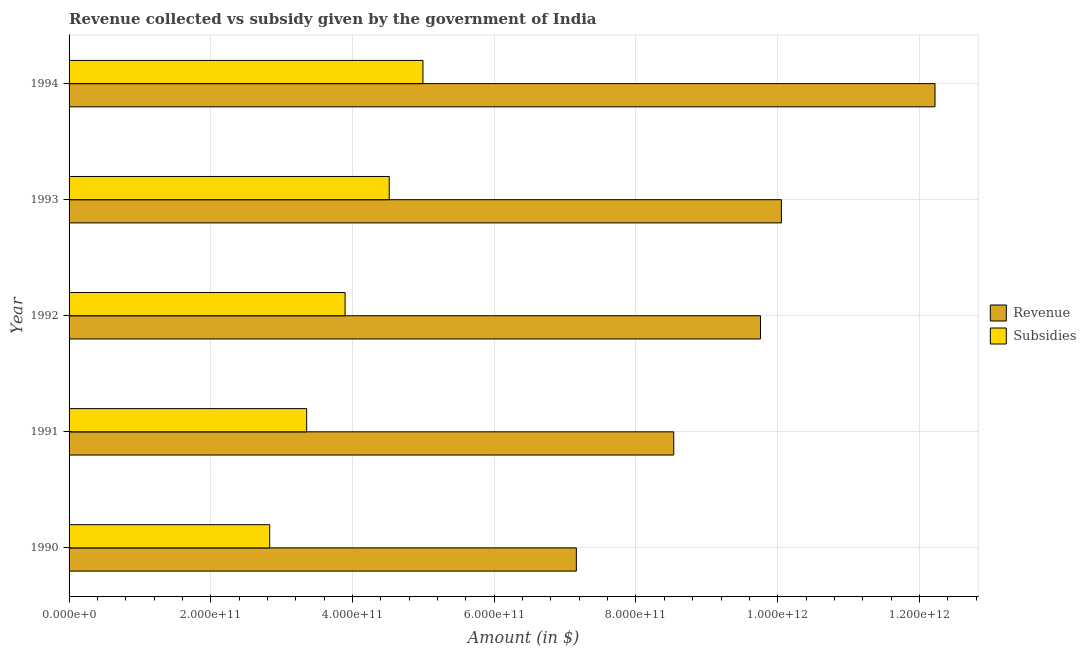Are the number of bars per tick equal to the number of legend labels?
Your response must be concise. Yes. How many bars are there on the 4th tick from the top?
Offer a very short reply. 2. How many bars are there on the 5th tick from the bottom?
Offer a terse response. 2. What is the amount of revenue collected in 1991?
Give a very brief answer. 8.53e+11. Across all years, what is the maximum amount of revenue collected?
Give a very brief answer. 1.22e+12. Across all years, what is the minimum amount of subsidies given?
Offer a terse response. 2.83e+11. What is the total amount of subsidies given in the graph?
Provide a succinct answer. 1.96e+12. What is the difference between the amount of revenue collected in 1990 and that in 1993?
Your answer should be very brief. -2.89e+11. What is the difference between the amount of subsidies given in 1993 and the amount of revenue collected in 1992?
Your answer should be compact. -5.24e+11. What is the average amount of revenue collected per year?
Your answer should be compact. 9.54e+11. In the year 1994, what is the difference between the amount of revenue collected and amount of subsidies given?
Keep it short and to the point. 7.23e+11. What is the ratio of the amount of revenue collected in 1993 to that in 1994?
Your answer should be very brief. 0.82. Is the amount of revenue collected in 1990 less than that in 1994?
Provide a short and direct response. Yes. What is the difference between the highest and the second highest amount of subsidies given?
Keep it short and to the point. 4.76e+1. What is the difference between the highest and the lowest amount of revenue collected?
Provide a short and direct response. 5.06e+11. In how many years, is the amount of subsidies given greater than the average amount of subsidies given taken over all years?
Provide a succinct answer. 2. Is the sum of the amount of revenue collected in 1990 and 1991 greater than the maximum amount of subsidies given across all years?
Give a very brief answer. Yes. What does the 1st bar from the top in 1993 represents?
Keep it short and to the point. Subsidies. What does the 1st bar from the bottom in 1991 represents?
Your answer should be very brief. Revenue. How many bars are there?
Offer a terse response. 10. Are all the bars in the graph horizontal?
Provide a succinct answer. Yes. How many years are there in the graph?
Offer a very short reply. 5. What is the difference between two consecutive major ticks on the X-axis?
Ensure brevity in your answer.  2.00e+11. Are the values on the major ticks of X-axis written in scientific E-notation?
Make the answer very short. Yes. Does the graph contain any zero values?
Ensure brevity in your answer.  No. Does the graph contain grids?
Your answer should be very brief. Yes. Where does the legend appear in the graph?
Give a very brief answer. Center right. What is the title of the graph?
Your response must be concise. Revenue collected vs subsidy given by the government of India. Does "Fixed telephone" appear as one of the legend labels in the graph?
Your answer should be compact. No. What is the label or title of the X-axis?
Provide a succinct answer. Amount (in $). What is the Amount (in $) in Revenue in 1990?
Your answer should be compact. 7.16e+11. What is the Amount (in $) in Subsidies in 1990?
Provide a short and direct response. 2.83e+11. What is the Amount (in $) in Revenue in 1991?
Provide a short and direct response. 8.53e+11. What is the Amount (in $) of Subsidies in 1991?
Your answer should be very brief. 3.35e+11. What is the Amount (in $) of Revenue in 1992?
Make the answer very short. 9.76e+11. What is the Amount (in $) of Subsidies in 1992?
Make the answer very short. 3.90e+11. What is the Amount (in $) in Revenue in 1993?
Your answer should be compact. 1.01e+12. What is the Amount (in $) in Subsidies in 1993?
Your response must be concise. 4.52e+11. What is the Amount (in $) of Revenue in 1994?
Your answer should be very brief. 1.22e+12. What is the Amount (in $) of Subsidies in 1994?
Provide a short and direct response. 4.99e+11. Across all years, what is the maximum Amount (in $) of Revenue?
Your answer should be compact. 1.22e+12. Across all years, what is the maximum Amount (in $) of Subsidies?
Ensure brevity in your answer.  4.99e+11. Across all years, what is the minimum Amount (in $) in Revenue?
Provide a succinct answer. 7.16e+11. Across all years, what is the minimum Amount (in $) in Subsidies?
Offer a very short reply. 2.83e+11. What is the total Amount (in $) in Revenue in the graph?
Provide a short and direct response. 4.77e+12. What is the total Amount (in $) of Subsidies in the graph?
Ensure brevity in your answer.  1.96e+12. What is the difference between the Amount (in $) of Revenue in 1990 and that in 1991?
Ensure brevity in your answer.  -1.37e+11. What is the difference between the Amount (in $) of Subsidies in 1990 and that in 1991?
Make the answer very short. -5.22e+1. What is the difference between the Amount (in $) of Revenue in 1990 and that in 1992?
Offer a terse response. -2.60e+11. What is the difference between the Amount (in $) of Subsidies in 1990 and that in 1992?
Give a very brief answer. -1.06e+11. What is the difference between the Amount (in $) in Revenue in 1990 and that in 1993?
Your response must be concise. -2.89e+11. What is the difference between the Amount (in $) of Subsidies in 1990 and that in 1993?
Your answer should be compact. -1.69e+11. What is the difference between the Amount (in $) in Revenue in 1990 and that in 1994?
Your answer should be compact. -5.06e+11. What is the difference between the Amount (in $) of Subsidies in 1990 and that in 1994?
Your answer should be very brief. -2.16e+11. What is the difference between the Amount (in $) of Revenue in 1991 and that in 1992?
Make the answer very short. -1.22e+11. What is the difference between the Amount (in $) of Subsidies in 1991 and that in 1992?
Make the answer very short. -5.42e+1. What is the difference between the Amount (in $) in Revenue in 1991 and that in 1993?
Provide a succinct answer. -1.52e+11. What is the difference between the Amount (in $) in Subsidies in 1991 and that in 1993?
Offer a very short reply. -1.16e+11. What is the difference between the Amount (in $) of Revenue in 1991 and that in 1994?
Ensure brevity in your answer.  -3.69e+11. What is the difference between the Amount (in $) in Subsidies in 1991 and that in 1994?
Make the answer very short. -1.64e+11. What is the difference between the Amount (in $) of Revenue in 1992 and that in 1993?
Provide a succinct answer. -2.95e+1. What is the difference between the Amount (in $) in Subsidies in 1992 and that in 1993?
Ensure brevity in your answer.  -6.23e+1. What is the difference between the Amount (in $) in Revenue in 1992 and that in 1994?
Keep it short and to the point. -2.46e+11. What is the difference between the Amount (in $) of Subsidies in 1992 and that in 1994?
Offer a terse response. -1.10e+11. What is the difference between the Amount (in $) in Revenue in 1993 and that in 1994?
Ensure brevity in your answer.  -2.17e+11. What is the difference between the Amount (in $) in Subsidies in 1993 and that in 1994?
Ensure brevity in your answer.  -4.76e+1. What is the difference between the Amount (in $) in Revenue in 1990 and the Amount (in $) in Subsidies in 1991?
Make the answer very short. 3.81e+11. What is the difference between the Amount (in $) in Revenue in 1990 and the Amount (in $) in Subsidies in 1992?
Your answer should be very brief. 3.26e+11. What is the difference between the Amount (in $) in Revenue in 1990 and the Amount (in $) in Subsidies in 1993?
Give a very brief answer. 2.64e+11. What is the difference between the Amount (in $) of Revenue in 1990 and the Amount (in $) of Subsidies in 1994?
Provide a short and direct response. 2.16e+11. What is the difference between the Amount (in $) in Revenue in 1991 and the Amount (in $) in Subsidies in 1992?
Your answer should be compact. 4.64e+11. What is the difference between the Amount (in $) of Revenue in 1991 and the Amount (in $) of Subsidies in 1993?
Keep it short and to the point. 4.02e+11. What is the difference between the Amount (in $) of Revenue in 1991 and the Amount (in $) of Subsidies in 1994?
Keep it short and to the point. 3.54e+11. What is the difference between the Amount (in $) of Revenue in 1992 and the Amount (in $) of Subsidies in 1993?
Offer a very short reply. 5.24e+11. What is the difference between the Amount (in $) of Revenue in 1992 and the Amount (in $) of Subsidies in 1994?
Offer a terse response. 4.76e+11. What is the difference between the Amount (in $) of Revenue in 1993 and the Amount (in $) of Subsidies in 1994?
Make the answer very short. 5.06e+11. What is the average Amount (in $) in Revenue per year?
Offer a terse response. 9.54e+11. What is the average Amount (in $) of Subsidies per year?
Your answer should be very brief. 3.92e+11. In the year 1990, what is the difference between the Amount (in $) in Revenue and Amount (in $) in Subsidies?
Your response must be concise. 4.33e+11. In the year 1991, what is the difference between the Amount (in $) in Revenue and Amount (in $) in Subsidies?
Make the answer very short. 5.18e+11. In the year 1992, what is the difference between the Amount (in $) of Revenue and Amount (in $) of Subsidies?
Provide a succinct answer. 5.86e+11. In the year 1993, what is the difference between the Amount (in $) of Revenue and Amount (in $) of Subsidies?
Provide a short and direct response. 5.53e+11. In the year 1994, what is the difference between the Amount (in $) of Revenue and Amount (in $) of Subsidies?
Provide a short and direct response. 7.23e+11. What is the ratio of the Amount (in $) of Revenue in 1990 to that in 1991?
Make the answer very short. 0.84. What is the ratio of the Amount (in $) of Subsidies in 1990 to that in 1991?
Give a very brief answer. 0.84. What is the ratio of the Amount (in $) in Revenue in 1990 to that in 1992?
Your answer should be very brief. 0.73. What is the ratio of the Amount (in $) of Subsidies in 1990 to that in 1992?
Keep it short and to the point. 0.73. What is the ratio of the Amount (in $) of Revenue in 1990 to that in 1993?
Your answer should be very brief. 0.71. What is the ratio of the Amount (in $) in Subsidies in 1990 to that in 1993?
Offer a terse response. 0.63. What is the ratio of the Amount (in $) in Revenue in 1990 to that in 1994?
Offer a very short reply. 0.59. What is the ratio of the Amount (in $) in Subsidies in 1990 to that in 1994?
Make the answer very short. 0.57. What is the ratio of the Amount (in $) in Revenue in 1991 to that in 1992?
Make the answer very short. 0.87. What is the ratio of the Amount (in $) of Subsidies in 1991 to that in 1992?
Your answer should be very brief. 0.86. What is the ratio of the Amount (in $) of Revenue in 1991 to that in 1993?
Ensure brevity in your answer.  0.85. What is the ratio of the Amount (in $) of Subsidies in 1991 to that in 1993?
Make the answer very short. 0.74. What is the ratio of the Amount (in $) of Revenue in 1991 to that in 1994?
Keep it short and to the point. 0.7. What is the ratio of the Amount (in $) of Subsidies in 1991 to that in 1994?
Keep it short and to the point. 0.67. What is the ratio of the Amount (in $) in Revenue in 1992 to that in 1993?
Offer a very short reply. 0.97. What is the ratio of the Amount (in $) in Subsidies in 1992 to that in 1993?
Provide a succinct answer. 0.86. What is the ratio of the Amount (in $) of Revenue in 1992 to that in 1994?
Offer a very short reply. 0.8. What is the ratio of the Amount (in $) in Subsidies in 1992 to that in 1994?
Give a very brief answer. 0.78. What is the ratio of the Amount (in $) in Revenue in 1993 to that in 1994?
Your answer should be very brief. 0.82. What is the ratio of the Amount (in $) of Subsidies in 1993 to that in 1994?
Your response must be concise. 0.9. What is the difference between the highest and the second highest Amount (in $) of Revenue?
Give a very brief answer. 2.17e+11. What is the difference between the highest and the second highest Amount (in $) in Subsidies?
Offer a very short reply. 4.76e+1. What is the difference between the highest and the lowest Amount (in $) in Revenue?
Offer a terse response. 5.06e+11. What is the difference between the highest and the lowest Amount (in $) in Subsidies?
Your response must be concise. 2.16e+11. 